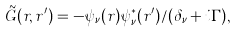Convert formula to latex. <formula><loc_0><loc_0><loc_500><loc_500>\tilde { G } ( { r } , { r } ^ { \prime } ) = - \psi _ { \nu } ( { r } ) \psi _ { \nu } ^ { * } ( { r } ^ { \prime } ) / ( \delta _ { \nu } + i \Gamma ) ,</formula> 